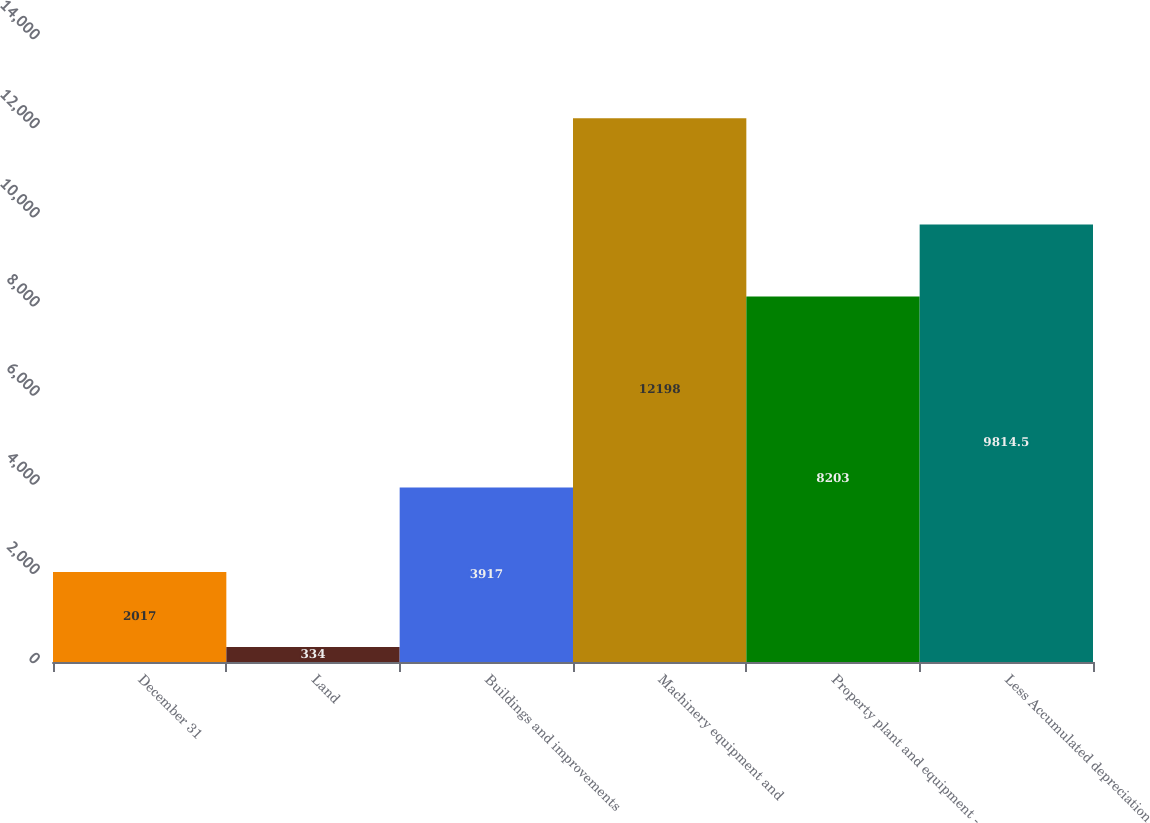<chart> <loc_0><loc_0><loc_500><loc_500><bar_chart><fcel>December 31<fcel>Land<fcel>Buildings and improvements<fcel>Machinery equipment and<fcel>Property plant and equipment -<fcel>Less Accumulated depreciation<nl><fcel>2017<fcel>334<fcel>3917<fcel>12198<fcel>8203<fcel>9814.5<nl></chart> 